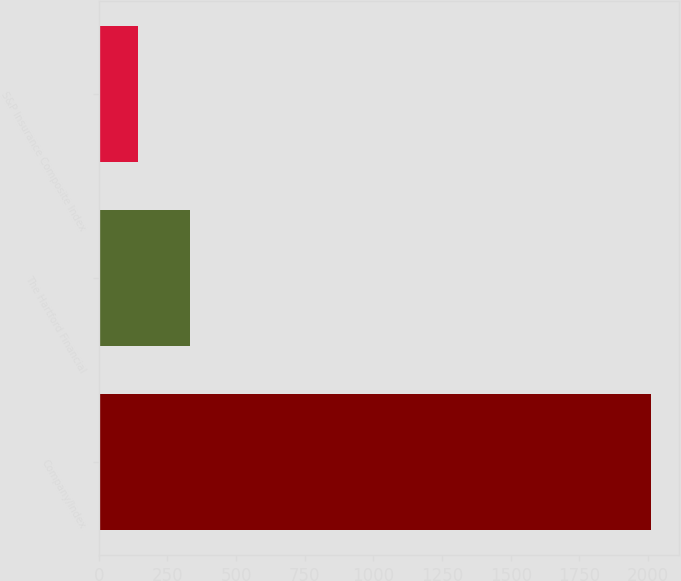Convert chart to OTSL. <chart><loc_0><loc_0><loc_500><loc_500><bar_chart><fcel>Company/Index<fcel>The Hartford Financial<fcel>S&P Insurance Composite Index<nl><fcel>2012<fcel>330.86<fcel>144.07<nl></chart> 